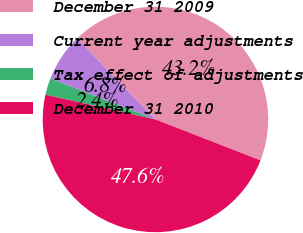<chart> <loc_0><loc_0><loc_500><loc_500><pie_chart><fcel>December 31 2009<fcel>Current year adjustments<fcel>Tax effect of adjustments<fcel>December 31 2010<nl><fcel>43.15%<fcel>6.85%<fcel>2.39%<fcel>47.61%<nl></chart> 